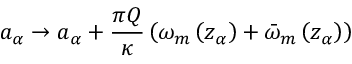Convert formula to latex. <formula><loc_0><loc_0><loc_500><loc_500>a _ { \alpha } \rightarrow a _ { \alpha } + \frac { \pi Q } { \kappa } \left ( \omega _ { m } \left ( z _ { \alpha } \right ) + \bar { \omega } _ { m } \left ( z _ { \alpha } \right ) \right )</formula> 